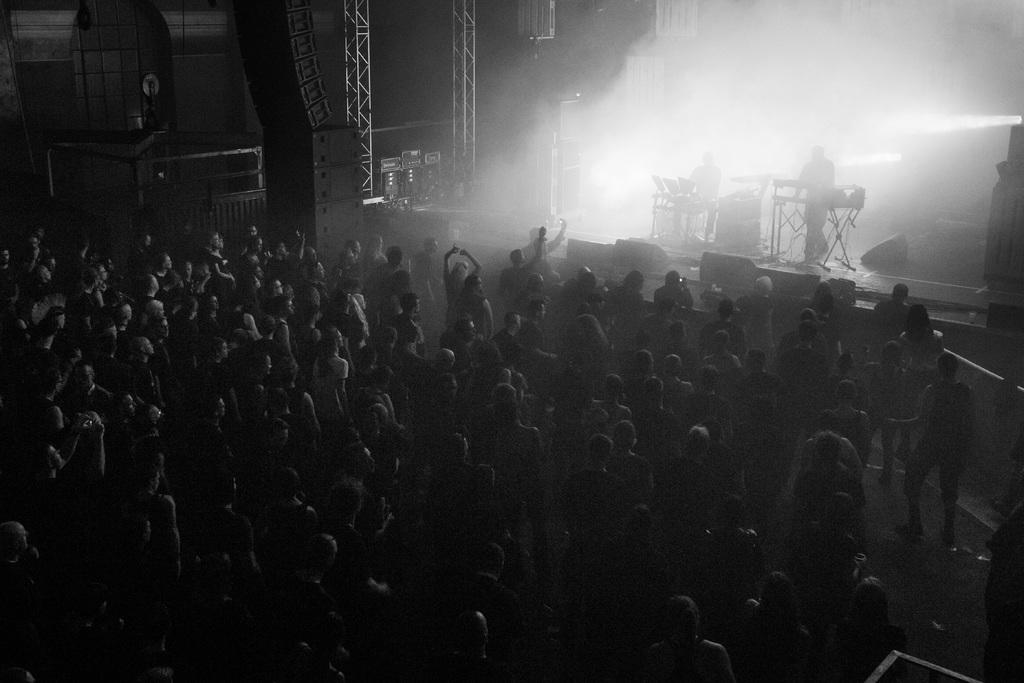How many people are in the image? There is a group of people standing in the image. What are two people doing in the image? Two people are on a stage. What else can be seen on the stage? There are other objects on the stage. What is the color scheme of the image? The image is black and white in color. What belief is being discussed by the people on the ship in the image? There is no ship present in the image; it features a group of people and a stage. 